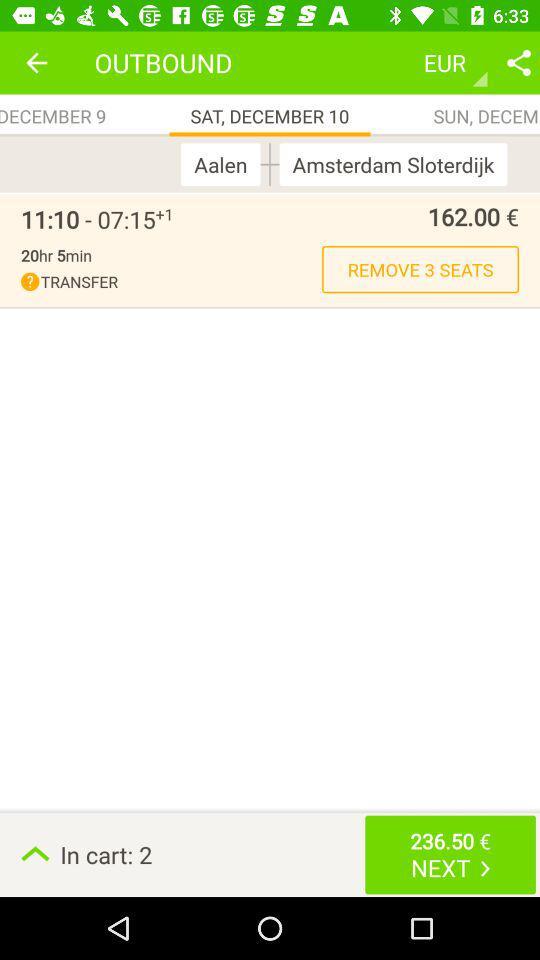How many seats can we remove? You can remove 3 seats. 